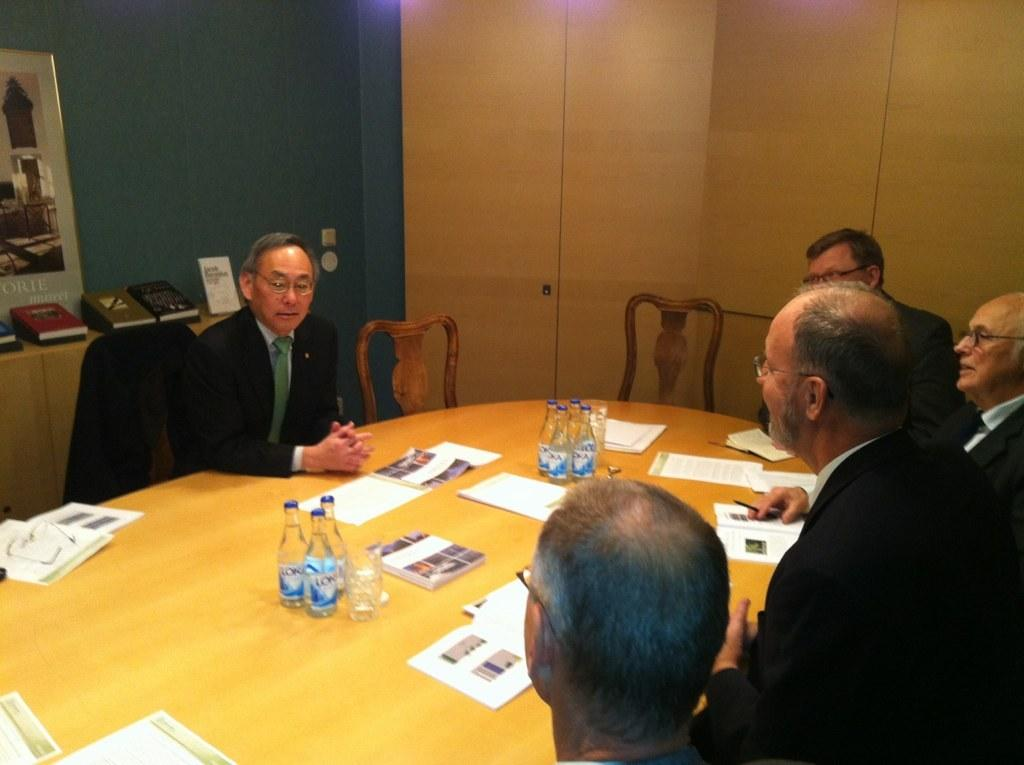What is happening in the image? There are persons sitting around a table in the image. What objects can be seen on the table? There are water bottles, books, papers, and glasses on the table. What is visible in the background of the image? In the background, there is a wall and photo frames. How does the pollution affect the table setting in the image? There is no indication of pollution in the image, so it cannot affect the table setting. 